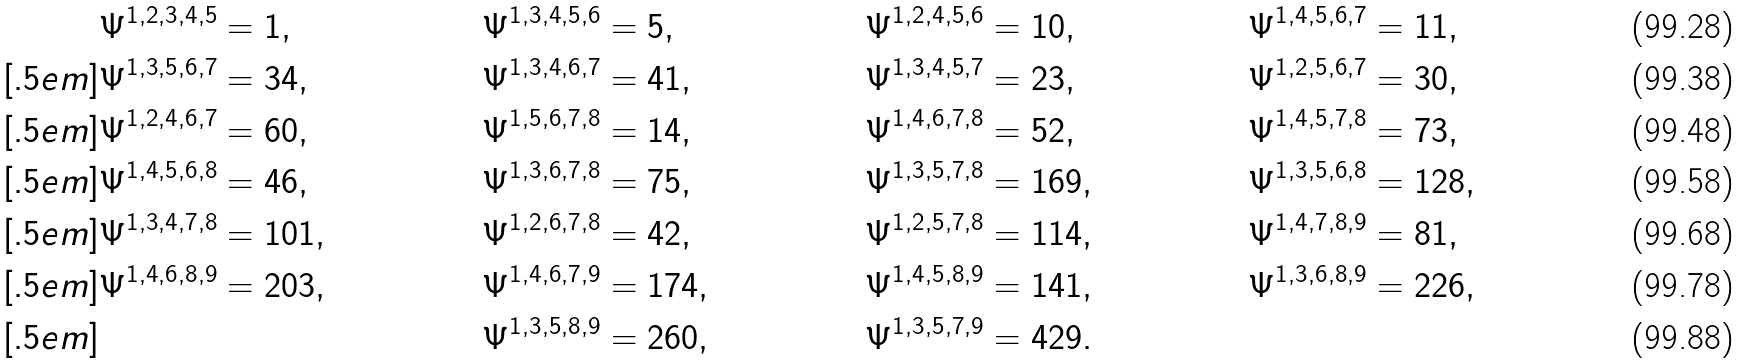<formula> <loc_0><loc_0><loc_500><loc_500>& \Psi ^ { 1 , 2 , 3 , 4 , 5 } = 1 , & & \Psi ^ { 1 , 3 , 4 , 5 , 6 } = 5 , & & \Psi ^ { 1 , 2 , 4 , 5 , 6 } = 1 0 , & & \Psi ^ { 1 , 4 , 5 , 6 , 7 } = 1 1 , \\ [ . 5 e m ] & \Psi ^ { 1 , 3 , 5 , 6 , 7 } = 3 4 , & & \Psi ^ { 1 , 3 , 4 , 6 , 7 } = 4 1 , & & \Psi ^ { 1 , 3 , 4 , 5 , 7 } = 2 3 , & & \Psi ^ { 1 , 2 , 5 , 6 , 7 } = 3 0 , \\ [ . 5 e m ] & \Psi ^ { 1 , 2 , 4 , 6 , 7 } = 6 0 , & & \Psi ^ { 1 , 5 , 6 , 7 , 8 } = 1 4 , & & \Psi ^ { 1 , 4 , 6 , 7 , 8 } = 5 2 , & & \Psi ^ { 1 , 4 , 5 , 7 , 8 } = 7 3 , \\ [ . 5 e m ] & \Psi ^ { 1 , 4 , 5 , 6 , 8 } = 4 6 , & & \Psi ^ { 1 , 3 , 6 , 7 , 8 } = 7 5 , & & \Psi ^ { 1 , 3 , 5 , 7 , 8 } = 1 6 9 , & & \Psi ^ { 1 , 3 , 5 , 6 , 8 } = 1 2 8 , \\ [ . 5 e m ] & \Psi ^ { 1 , 3 , 4 , 7 , 8 } = 1 0 1 , & & \Psi ^ { 1 , 2 , 6 , 7 , 8 } = 4 2 , & & \Psi ^ { 1 , 2 , 5 , 7 , 8 } = 1 1 4 , & & \Psi ^ { 1 , 4 , 7 , 8 , 9 } = 8 1 , \\ [ . 5 e m ] & \Psi ^ { 1 , 4 , 6 , 8 , 9 } = 2 0 3 , & & \Psi ^ { 1 , 4 , 6 , 7 , 9 } = 1 7 4 , & & \Psi ^ { 1 , 4 , 5 , 8 , 9 } = 1 4 1 , & & \Psi ^ { 1 , 3 , 6 , 8 , 9 } = 2 2 6 , \\ [ . 5 e m ] & & & \Psi ^ { 1 , 3 , 5 , 8 , 9 } = 2 6 0 , & & \Psi ^ { 1 , 3 , 5 , 7 , 9 } = 4 2 9 . &</formula> 